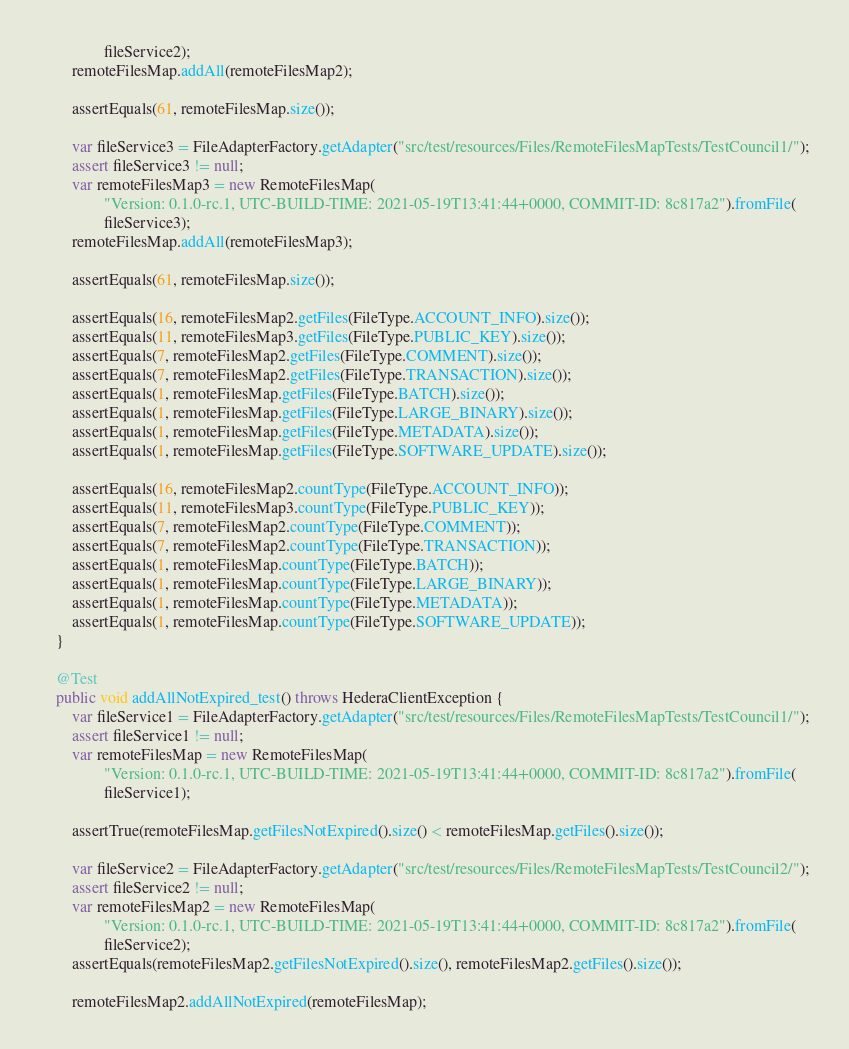<code> <loc_0><loc_0><loc_500><loc_500><_Java_>				fileService2);
		remoteFilesMap.addAll(remoteFilesMap2);

		assertEquals(61, remoteFilesMap.size());

		var fileService3 = FileAdapterFactory.getAdapter("src/test/resources/Files/RemoteFilesMapTests/TestCouncil1/");
		assert fileService3 != null;
		var remoteFilesMap3 = new RemoteFilesMap(
				"Version: 0.1.0-rc.1, UTC-BUILD-TIME: 2021-05-19T13:41:44+0000, COMMIT-ID: 8c817a2").fromFile(
				fileService3);
		remoteFilesMap.addAll(remoteFilesMap3);

		assertEquals(61, remoteFilesMap.size());

		assertEquals(16, remoteFilesMap2.getFiles(FileType.ACCOUNT_INFO).size());
		assertEquals(11, remoteFilesMap3.getFiles(FileType.PUBLIC_KEY).size());
		assertEquals(7, remoteFilesMap2.getFiles(FileType.COMMENT).size());
		assertEquals(7, remoteFilesMap2.getFiles(FileType.TRANSACTION).size());
		assertEquals(1, remoteFilesMap.getFiles(FileType.BATCH).size());
		assertEquals(1, remoteFilesMap.getFiles(FileType.LARGE_BINARY).size());
		assertEquals(1, remoteFilesMap.getFiles(FileType.METADATA).size());
		assertEquals(1, remoteFilesMap.getFiles(FileType.SOFTWARE_UPDATE).size());

		assertEquals(16, remoteFilesMap2.countType(FileType.ACCOUNT_INFO));
		assertEquals(11, remoteFilesMap3.countType(FileType.PUBLIC_KEY));
		assertEquals(7, remoteFilesMap2.countType(FileType.COMMENT));
		assertEquals(7, remoteFilesMap2.countType(FileType.TRANSACTION));
		assertEquals(1, remoteFilesMap.countType(FileType.BATCH));
		assertEquals(1, remoteFilesMap.countType(FileType.LARGE_BINARY));
		assertEquals(1, remoteFilesMap.countType(FileType.METADATA));
		assertEquals(1, remoteFilesMap.countType(FileType.SOFTWARE_UPDATE));
	}

	@Test
	public void addAllNotExpired_test() throws HederaClientException {
		var fileService1 = FileAdapterFactory.getAdapter("src/test/resources/Files/RemoteFilesMapTests/TestCouncil1/");
		assert fileService1 != null;
		var remoteFilesMap = new RemoteFilesMap(
				"Version: 0.1.0-rc.1, UTC-BUILD-TIME: 2021-05-19T13:41:44+0000, COMMIT-ID: 8c817a2").fromFile(
				fileService1);

		assertTrue(remoteFilesMap.getFilesNotExpired().size() < remoteFilesMap.getFiles().size());

		var fileService2 = FileAdapterFactory.getAdapter("src/test/resources/Files/RemoteFilesMapTests/TestCouncil2/");
		assert fileService2 != null;
		var remoteFilesMap2 = new RemoteFilesMap(
				"Version: 0.1.0-rc.1, UTC-BUILD-TIME: 2021-05-19T13:41:44+0000, COMMIT-ID: 8c817a2").fromFile(
				fileService2);
		assertEquals(remoteFilesMap2.getFilesNotExpired().size(), remoteFilesMap2.getFiles().size());

		remoteFilesMap2.addAllNotExpired(remoteFilesMap);</code> 